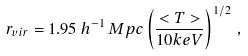<formula> <loc_0><loc_0><loc_500><loc_500>r _ { v i r } = 1 . 9 5 \, { h } ^ { - 1 } \, { M p c } \left ( \frac { < T > } { 1 0 { k e V } } \right ) ^ { 1 / 2 } \, ,</formula> 